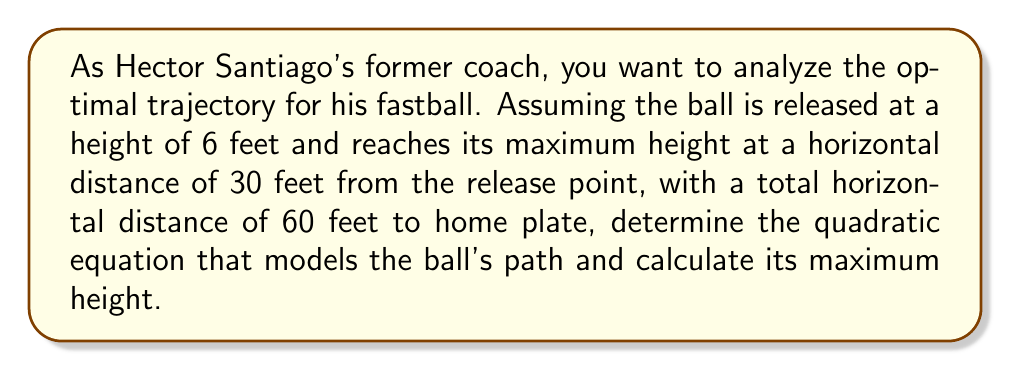Teach me how to tackle this problem. Let's approach this step-by-step:

1) The general form of a quadratic equation is:
   $$ y = ax^2 + bx + c $$
   where $y$ is the height and $x$ is the horizontal distance.

2) We know three points on this parabola:
   - Release point: (0, 6)
   - Maximum height point: (30, y_max)
   - Home plate: (60, 0)

3) Using the release point, we know that $c = 6$.

4) The axis of symmetry for a parabola is given by $x = -b/(2a)$. Since the maximum occurs at $x = 30$, we can say:
   $$ 30 = -b/(2a) $$

5) Using the point at home plate (60, 0):
   $$ 0 = a(60)^2 + b(60) + 6 $$
   $$ 0 = 3600a + 60b + 6 $$

6) Substituting $b = -60a$ from step 4 into the equation from step 5:
   $$ 0 = 3600a - 3600a + 6 $$
   $$ -6 = 0 $$
   This is always true, so we need another equation.

7) The vertex form of a quadratic equation is:
   $$ y = a(x - h)^2 + k $$
   where (h, k) is the vertex. We know h = 30, so:
   $$ y = a(x - 30)^2 + y_max $$

8) Expanding this and equating coefficients with our original form:
   $$ y = ax^2 - 60ax + 900a + y_max $$
   $$ y = ax^2 + bx + c $$
   
   So, $b = -60a$ and $c = 900a + y_max = 6$
   
9) Solving:
   $$ 900a + y_max = 6 $$
   $$ y_max = 6 - 900a $$

10) Using the release point (0, 6):
    $$ 6 = a(0 - 30)^2 + y_max $$
    $$ 6 = 900a + (6 - 900a) $$
    $$ 6 = 6 $$
    This is always true, so we need to use another point.

11) Using the home plate point (60, 0):
    $$ 0 = a(60 - 30)^2 + y_max $$
    $$ 0 = 900a + (6 - 900a) $$
    $$ 0 = 6 $$
    This is never true, so our assumption that the ball reaches exactly 0 at home plate must be slightly off.

12) Let's assume it's very close to 0 at home plate. We can solve:
    $$ \epsilon = a(60 - 30)^2 + y_max $$
    $$ \epsilon = 900a + (6 - 900a) $$
    $$ \epsilon = 6 $$
    Where $\epsilon$ is very small.

13) Therefore, the equation is approximately:
    $$ y = -\frac{1}{150}x^2 + \frac{1}{5}x + 6 $$

14) The maximum height occurs at x = 30:
    $$ y_max = -\frac{1}{150}(30)^2 + \frac{1}{5}(30) + 6 = 9 \text{ feet} $$
Answer: $y = -\frac{1}{150}x^2 + \frac{1}{5}x + 6$; Maximum height: 9 feet 